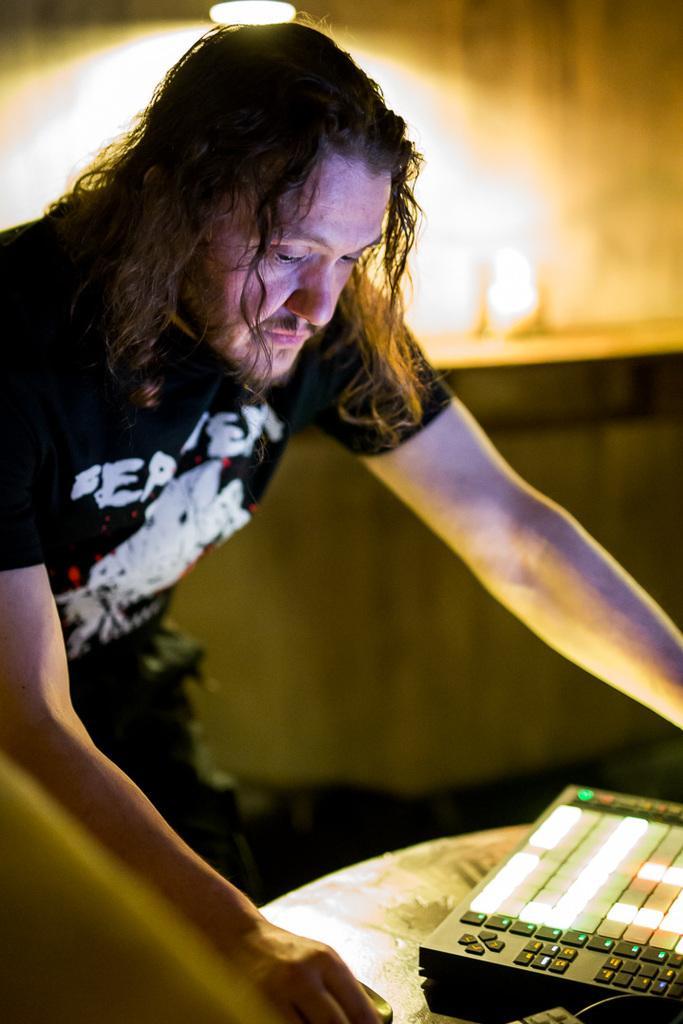How would you summarize this image in a sentence or two? There is a man standing,in front of this man we can see objects on the table. Background it is blurry and we can see light. 